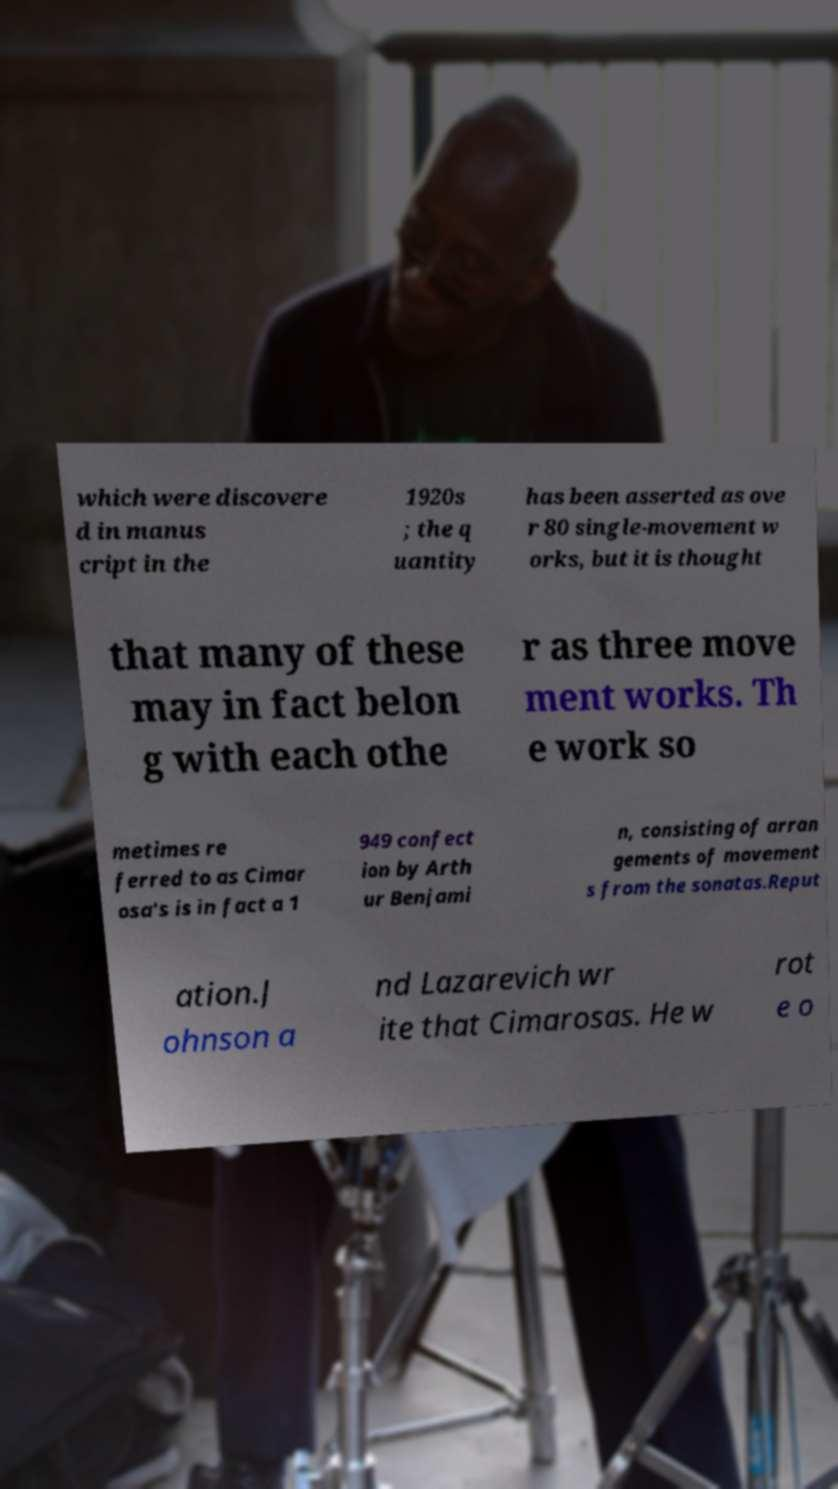Could you extract and type out the text from this image? which were discovere d in manus cript in the 1920s ; the q uantity has been asserted as ove r 80 single-movement w orks, but it is thought that many of these may in fact belon g with each othe r as three move ment works. Th e work so metimes re ferred to as Cimar osa's is in fact a 1 949 confect ion by Arth ur Benjami n, consisting of arran gements of movement s from the sonatas.Reput ation.J ohnson a nd Lazarevich wr ite that Cimarosas. He w rot e o 